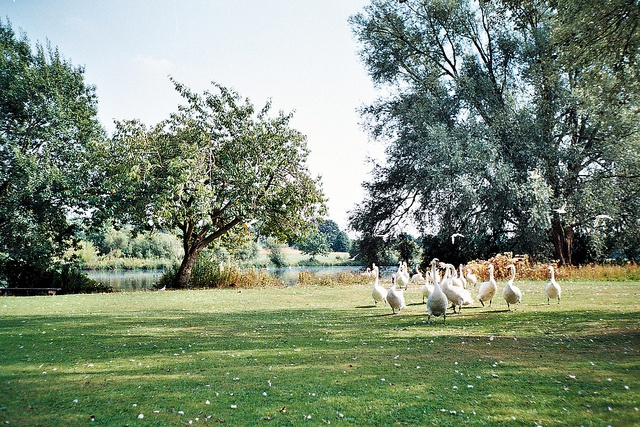Describe the objects in this image and their specific colors. I can see bird in lightblue, black, white, gray, and darkgray tones, bird in lightblue, lightgray, darkgray, gray, and black tones, bird in lightblue, white, darkgray, gray, and beige tones, bird in lightblue, white, olive, beige, and darkgray tones, and bird in lightblue, lightgray, and tan tones in this image. 